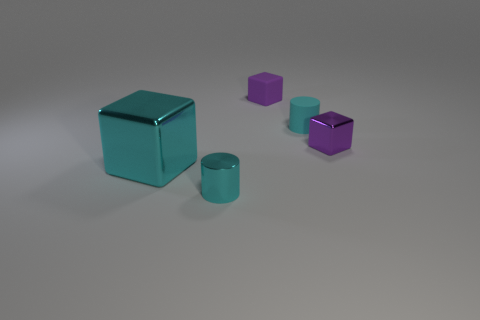Add 4 big cyan shiny objects. How many objects exist? 9 Subtract all cubes. How many objects are left? 2 Subtract all purple cubes. How many cubes are left? 1 Subtract all large cyan cubes. How many cubes are left? 2 Subtract 0 purple balls. How many objects are left? 5 Subtract 2 cylinders. How many cylinders are left? 0 Subtract all brown cylinders. Subtract all gray cubes. How many cylinders are left? 2 Subtract all blue cubes. How many gray cylinders are left? 0 Subtract all purple blocks. Subtract all large cyan metal objects. How many objects are left? 2 Add 2 cyan rubber cylinders. How many cyan rubber cylinders are left? 3 